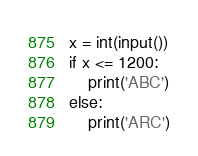Convert code to text. <code><loc_0><loc_0><loc_500><loc_500><_Python_>x = int(input())
if x <= 1200:
	print('ABC')
else:
	print('ARC')</code> 